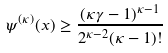<formula> <loc_0><loc_0><loc_500><loc_500>\psi ^ { ( \kappa ) } ( x ) \geq \frac { ( \kappa \gamma - 1 ) ^ { \kappa - 1 } } { 2 ^ { \kappa - 2 } ( \kappa - 1 ) ! }</formula> 